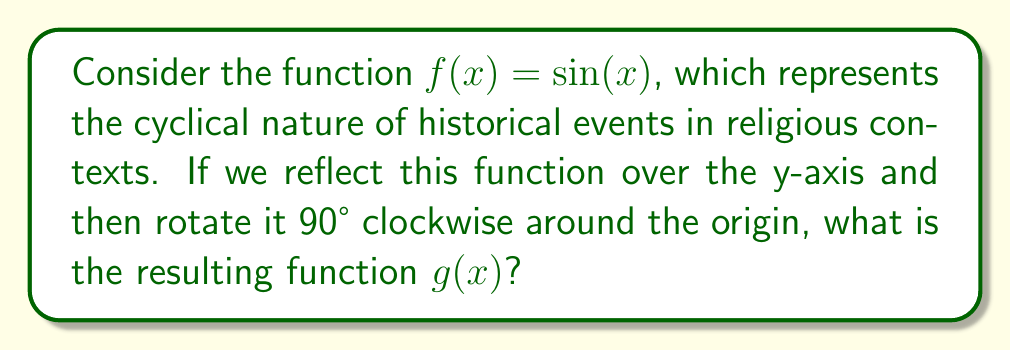What is the answer to this math problem? 1. First, let's reflect $f(x) = \sin(x)$ over the y-axis:
   - Reflection over the y-axis changes $x$ to $-x$
   - The reflected function is $\sin(-x)$
   - We know that $\sin(-x) = -\sin(x)$, so the reflected function is $-\sin(x)$

2. Now, we need to rotate this reflected function 90° clockwise around the origin:
   - A 90° clockwise rotation is equivalent to replacing $x$ with $y$ and $y$ with $-x$
   - Our current function is $y = -\sin(x)$
   - After rotation, this becomes $x = -\sin(y)$

3. To express this as a function of $x$, we need to solve for $y$:
   $x = -\sin(y)$
   $-x = \sin(y)$
   $y = \arcsin(-x)$

4. Therefore, the final function $g(x)$ is:
   $g(x) = \arcsin(-x)$

This transformation symbolizes how historical events in religious contexts can be viewed from different perspectives (reflection) and how their interpretation can shift over time (rotation), while still maintaining their fundamental cyclical nature.
Answer: $g(x) = \arcsin(-x)$ 